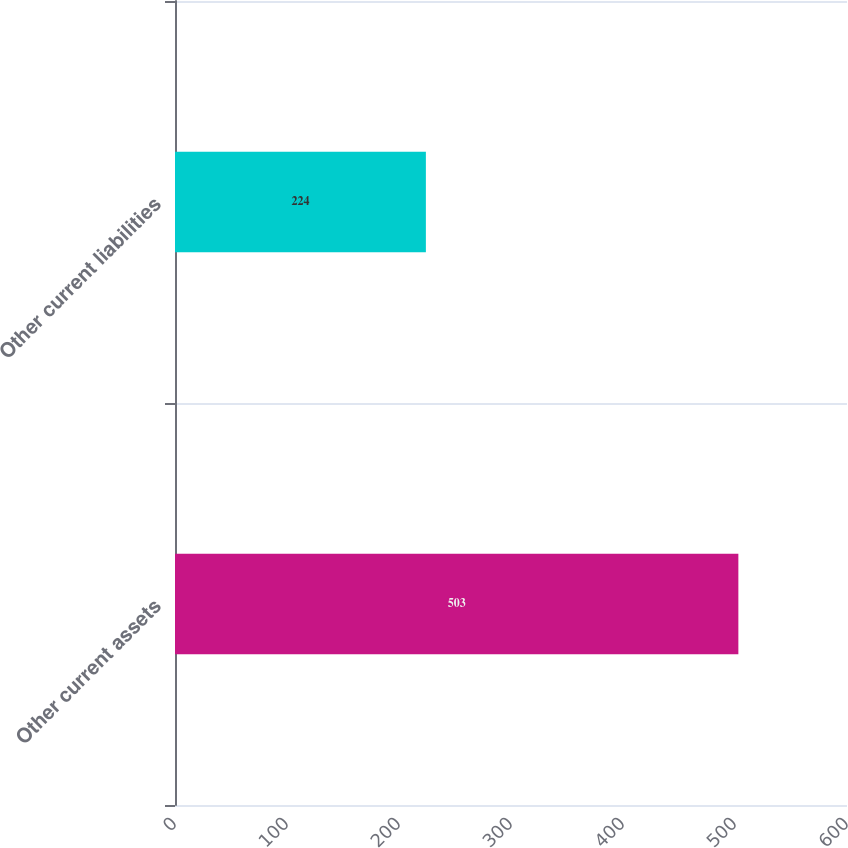Convert chart to OTSL. <chart><loc_0><loc_0><loc_500><loc_500><bar_chart><fcel>Other current assets<fcel>Other current liabilities<nl><fcel>503<fcel>224<nl></chart> 